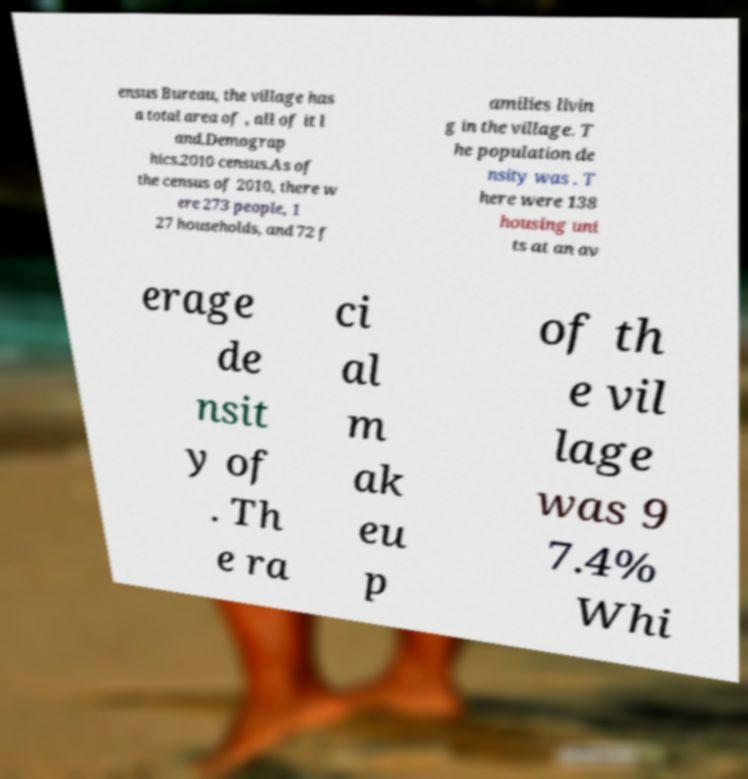For documentation purposes, I need the text within this image transcribed. Could you provide that? ensus Bureau, the village has a total area of , all of it l and.Demograp hics.2010 census.As of the census of 2010, there w ere 273 people, 1 27 households, and 72 f amilies livin g in the village. T he population de nsity was . T here were 138 housing uni ts at an av erage de nsit y of . Th e ra ci al m ak eu p of th e vil lage was 9 7.4% Whi 